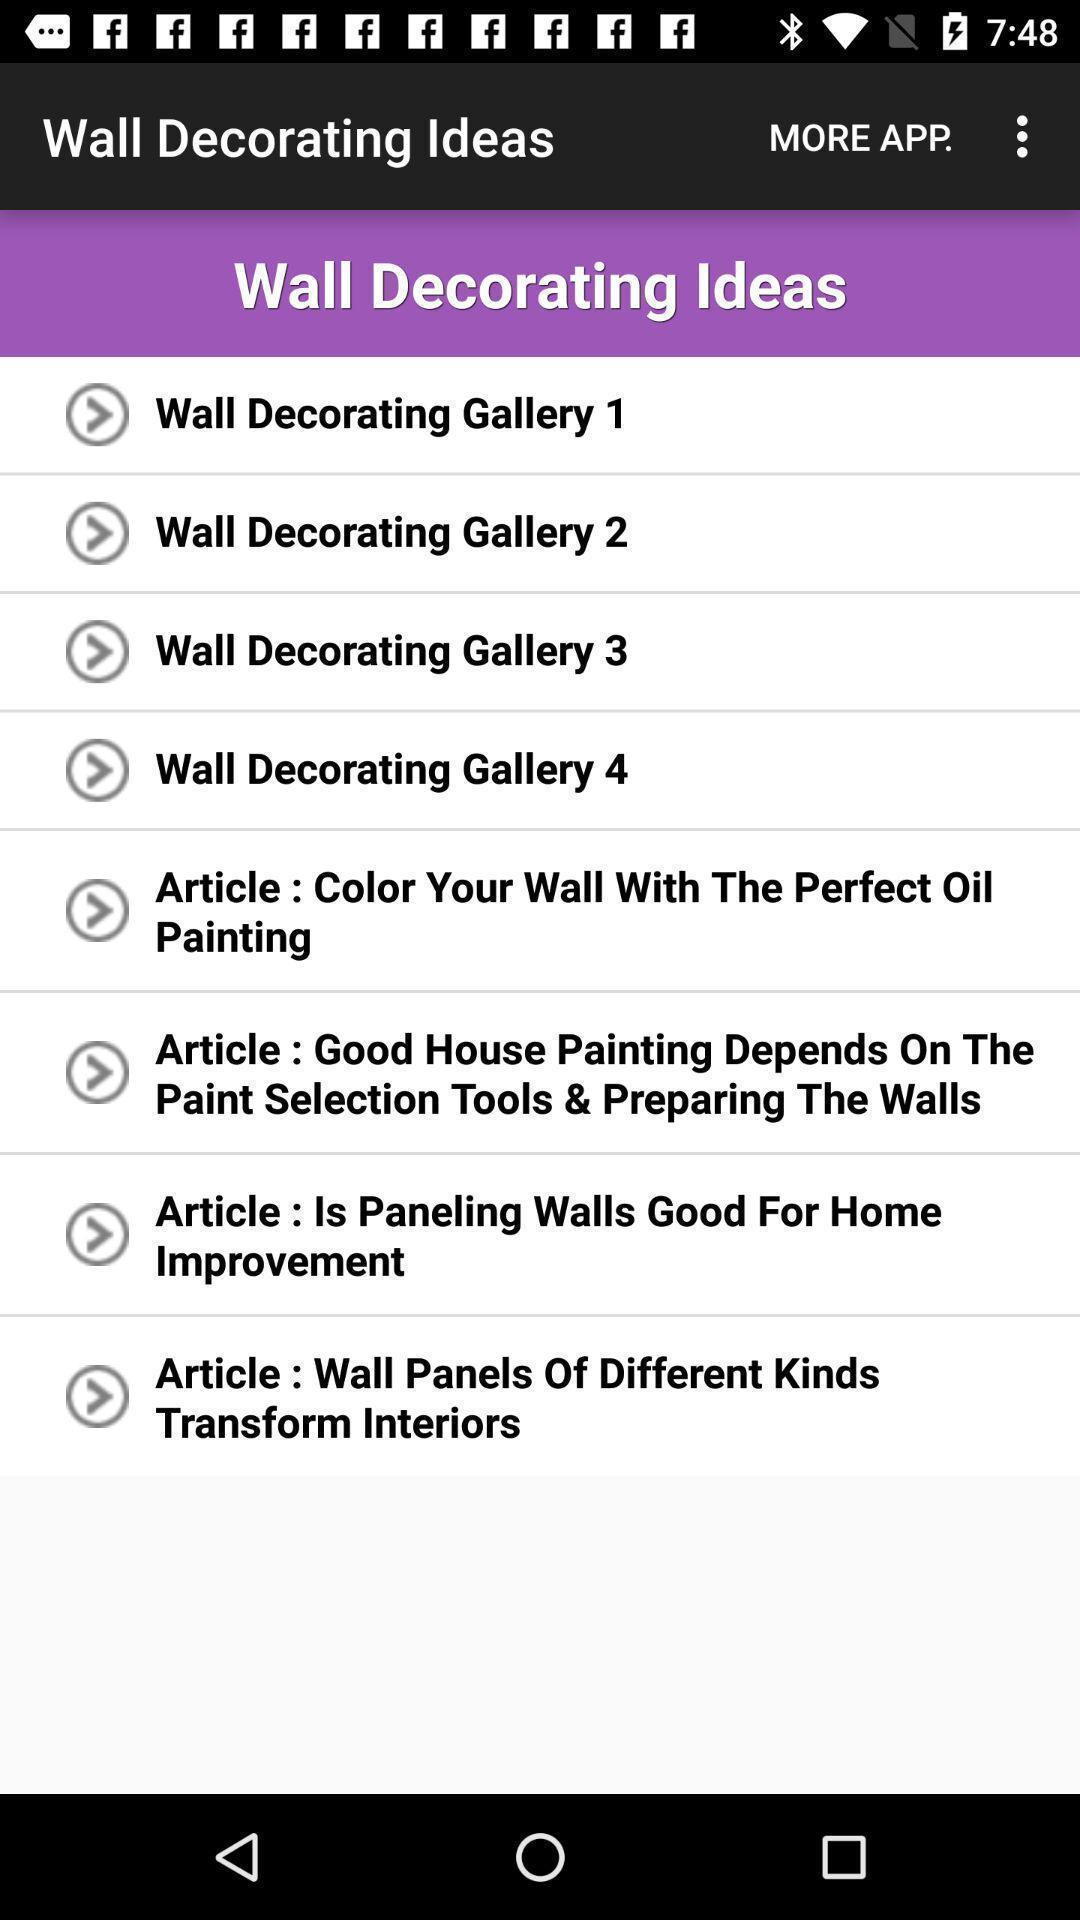Provide a description of this screenshot. Page displaying various information. 